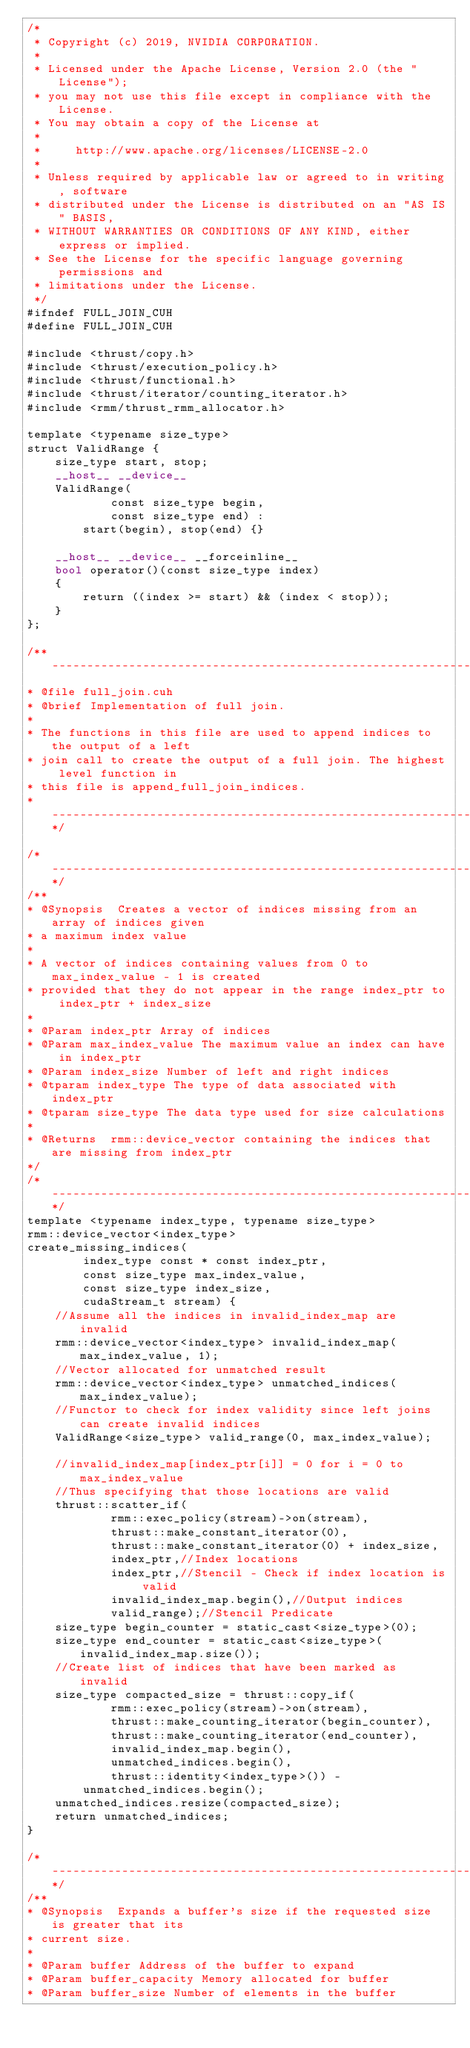<code> <loc_0><loc_0><loc_500><loc_500><_Cuda_>/*
 * Copyright (c) 2019, NVIDIA CORPORATION.
 *
 * Licensed under the Apache License, Version 2.0 (the "License");
 * you may not use this file except in compliance with the License.
 * You may obtain a copy of the License at
 *
 *     http://www.apache.org/licenses/LICENSE-2.0
 *
 * Unless required by applicable law or agreed to in writing, software
 * distributed under the License is distributed on an "AS IS" BASIS,
 * WITHOUT WARRANTIES OR CONDITIONS OF ANY KIND, either express or implied.
 * See the License for the specific language governing permissions and
 * limitations under the License.
 */
#ifndef FULL_JOIN_CUH
#define FULL_JOIN_CUH

#include <thrust/copy.h>
#include <thrust/execution_policy.h>
#include <thrust/functional.h>
#include <thrust/iterator/counting_iterator.h>
#include <rmm/thrust_rmm_allocator.h>

template <typename size_type>
struct ValidRange {
    size_type start, stop;
    __host__ __device__
    ValidRange(
            const size_type begin,
            const size_type end) :
        start(begin), stop(end) {}

    __host__ __device__ __forceinline__
    bool operator()(const size_type index)
    {
        return ((index >= start) && (index < stop));
    }
};

/** ---------------------------------------------------------------------------*
* @file full_join.cuh
* @brief Implementation of full join.
*
* The functions in this file are used to append indices to the output of a left
* join call to create the output of a full join. The highest level function in
* this file is append_full_join_indices.
* ---------------------------------------------------------------------------**/

/* --------------------------------------------------------------------------*/
/**
* @Synopsis  Creates a vector of indices missing from an array of indices given
* a maximum index value
*
* A vector of indices containing values from 0 to max_index_value - 1 is created
* provided that they do not appear in the range index_ptr to index_ptr + index_size
*
* @Param index_ptr Array of indices
* @Param max_index_value The maximum value an index can have in index_ptr
* @Param index_size Number of left and right indices
* @tparam index_type The type of data associated with index_ptr
* @tparam size_type The data type used for size calculations
*
* @Returns  rmm::device_vector containing the indices that are missing from index_ptr
*/
/* ----------------------------------------------------------------------------*/
template <typename index_type, typename size_type>
rmm::device_vector<index_type>
create_missing_indices(
        index_type const * const index_ptr,
        const size_type max_index_value,
        const size_type index_size,
        cudaStream_t stream) {
    //Assume all the indices in invalid_index_map are invalid
    rmm::device_vector<index_type> invalid_index_map(max_index_value, 1);
    //Vector allocated for unmatched result
    rmm::device_vector<index_type> unmatched_indices(max_index_value);
    //Functor to check for index validity since left joins can create invalid indices
    ValidRange<size_type> valid_range(0, max_index_value);

    //invalid_index_map[index_ptr[i]] = 0 for i = 0 to max_index_value
    //Thus specifying that those locations are valid
    thrust::scatter_if(
            rmm::exec_policy(stream)->on(stream),
            thrust::make_constant_iterator(0),
            thrust::make_constant_iterator(0) + index_size,
            index_ptr,//Index locations
            index_ptr,//Stencil - Check if index location is valid
            invalid_index_map.begin(),//Output indices
            valid_range);//Stencil Predicate
    size_type begin_counter = static_cast<size_type>(0);
    size_type end_counter = static_cast<size_type>(invalid_index_map.size());
    //Create list of indices that have been marked as invalid
    size_type compacted_size = thrust::copy_if(
            rmm::exec_policy(stream)->on(stream),
            thrust::make_counting_iterator(begin_counter),
            thrust::make_counting_iterator(end_counter),
            invalid_index_map.begin(),
            unmatched_indices.begin(),
            thrust::identity<index_type>()) -
        unmatched_indices.begin();
    unmatched_indices.resize(compacted_size);
    return unmatched_indices;
}

/* --------------------------------------------------------------------------*/
/**
* @Synopsis  Expands a buffer's size if the requested size is greater that its
* current size.
*
* @Param buffer Address of the buffer to expand
* @Param buffer_capacity Memory allocated for buffer
* @Param buffer_size Number of elements in the buffer</code> 